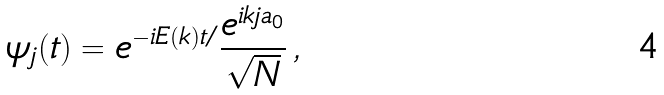<formula> <loc_0><loc_0><loc_500><loc_500>\psi _ { j } ( t ) = e ^ { - i E ( k ) t / } \frac { e ^ { i k j a _ { 0 } } } { \sqrt { N } } \, ,</formula> 